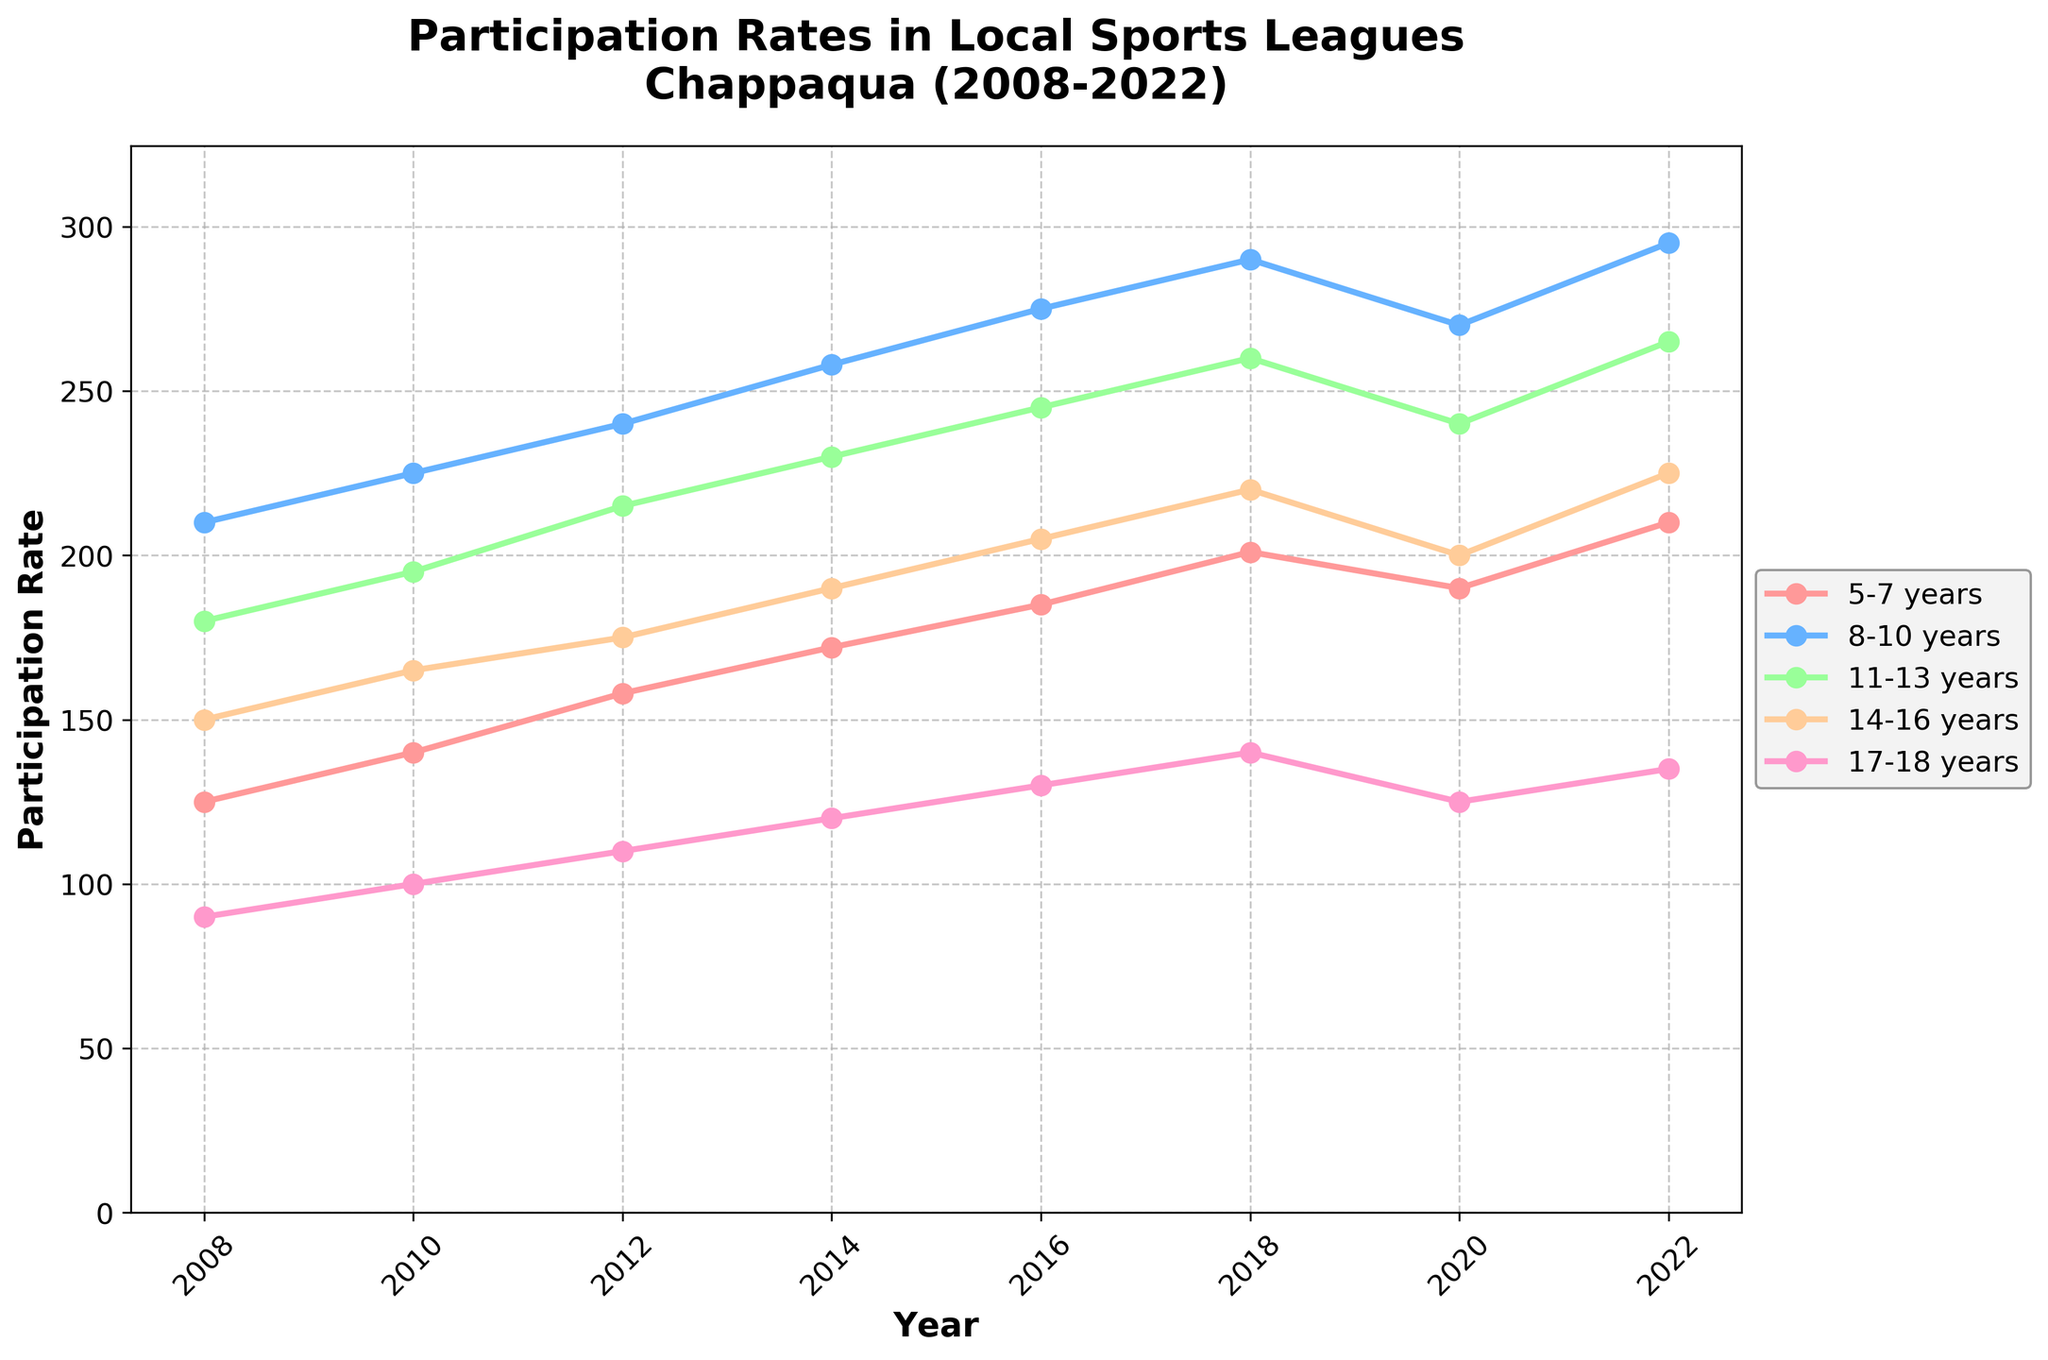When was the participation rate for the 5-7 years age group the highest? The highest participation rate for the 5-7 years age group can be determined by examining the peak of the line corresponding to this age group. The highest value is 210 in 2022.
Answer: 2022 Which age group has shown the most consistent increase in participation over the 15 years? By visually inspecting the slopes of the lines for all age groups, the 8-10 years age group exhibits a steady rise without any dips, indicating the most consistent increase.
Answer: 8-10 years How many age groups had a lower participation rate in 2020 compared to 2018? By comparing the values for each age group in 2018 and 2020, we find that the 5-7 years, 8-10 years, 11-13 years, and 14-16 years age groups all had lower participation rates in 2020 compared to 2018.
Answer: 4 Between which years did the 11-13 years age group experience the sharpest increase in participation rate? By estimating the slopes of the line segments for the 11-13 years age group, the sharpest increase appears between 2008 and 2012, where the rate jumped from 180 to 215.
Answer: 2008-2012 What is the difference in participation rates between the 8-10 years age group and the 17-18 years age group in 2016? The participation rate of the 8-10 years age group in 2016 is 275, and for the 17-18 years age group, it is 130. The difference is 275 - 130 = 145.
Answer: 145 Which age group had the steepest decline in participation from 2018 to 2020? By observing the slope of the lines from 2018 to 2020, the 17-18 years age group had the steepest decline, dropping from 140 to 125.
Answer: 17-18 years Is the participation rate for the 14-16 years age group in 2014 greater than that for the 11-13 years age group in 2008? The participation rate for the 14-16 years age group in 2014 is 190, while for the 11-13 years age group in 2008, it is 180. 190 is greater than 180.
Answer: Yes What is the average participation rate for the 5-7 years age group from 2008 to 2022? The participation rates for the 5-7 years age group are 125, 140, 158, 172, 185, 201, 190, 210. The average is (125 + 140 + 158 + 172 + 185 + 201 + 190 + 210) / 8 = 172.625.
Answer: 172.625 